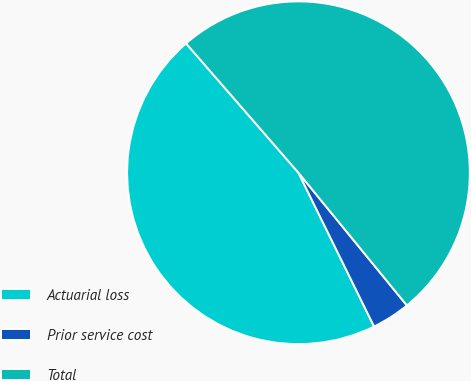Convert chart. <chart><loc_0><loc_0><loc_500><loc_500><pie_chart><fcel>Actuarial loss<fcel>Prior service cost<fcel>Total<nl><fcel>45.89%<fcel>3.63%<fcel>50.48%<nl></chart> 